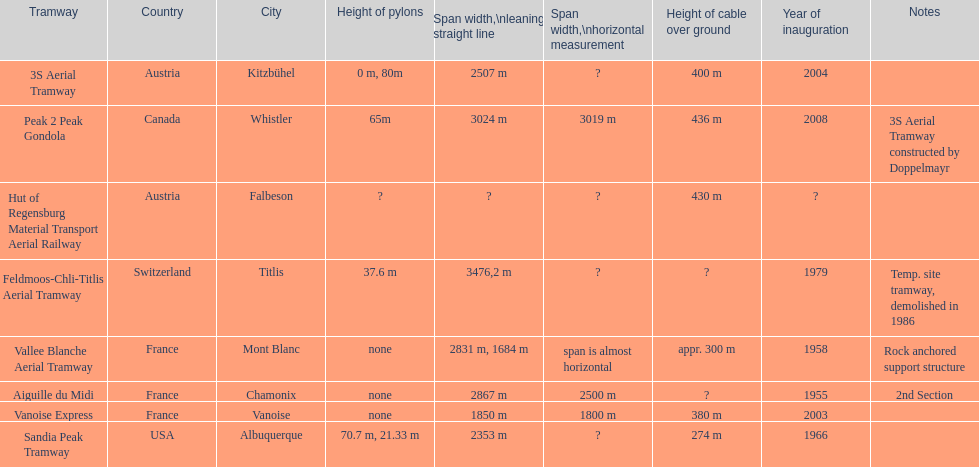When was the aiguille du midi tramway inaugurated? 1955. When was the 3s aerial tramway inaugurated? 2004. Which one was inaugurated first? Aiguille du Midi. 